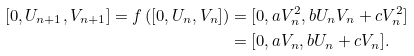<formula> <loc_0><loc_0><loc_500><loc_500>[ 0 , U _ { n + 1 } , V _ { n + 1 } ] = f \left ( [ 0 , U _ { n } , V _ { n } ] \right ) & = [ 0 , a V _ { n } ^ { 2 } , b U _ { n } V _ { n } + c V _ { n } ^ { 2 } ] \\ & = [ 0 , a V _ { n } , b U _ { n } + c V _ { n } ] .</formula> 